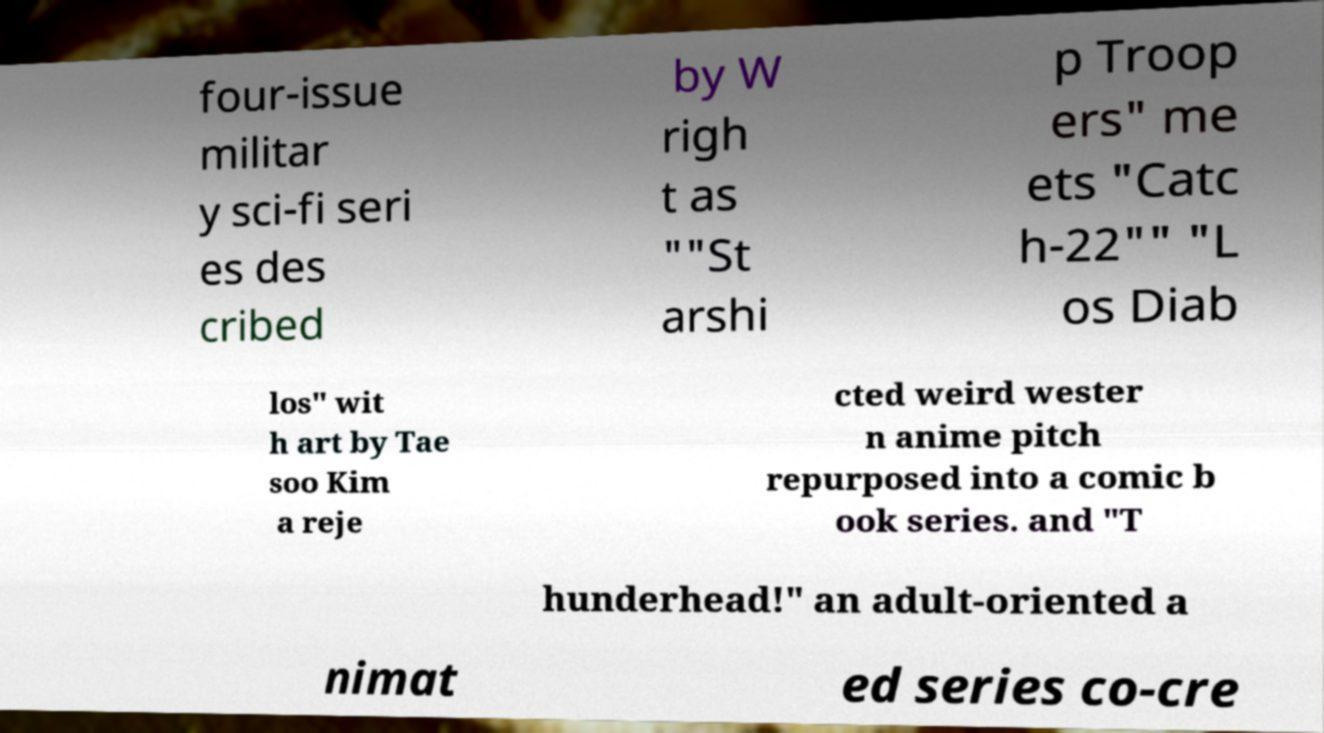What messages or text are displayed in this image? I need them in a readable, typed format. four-issue militar y sci-fi seri es des cribed by W righ t as ""St arshi p Troop ers" me ets "Catc h-22"" "L os Diab los" wit h art by Tae soo Kim a reje cted weird wester n anime pitch repurposed into a comic b ook series. and "T hunderhead!" an adult-oriented a nimat ed series co-cre 